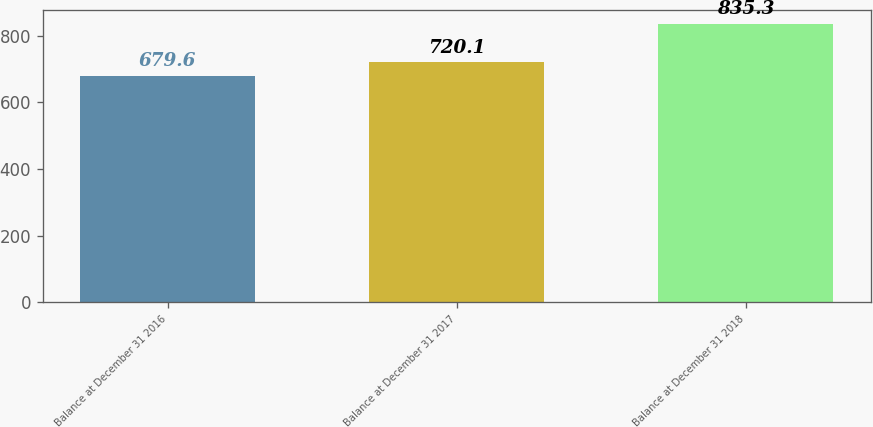Convert chart. <chart><loc_0><loc_0><loc_500><loc_500><bar_chart><fcel>Balance at December 31 2016<fcel>Balance at December 31 2017<fcel>Balance at December 31 2018<nl><fcel>679.6<fcel>720.1<fcel>835.3<nl></chart> 